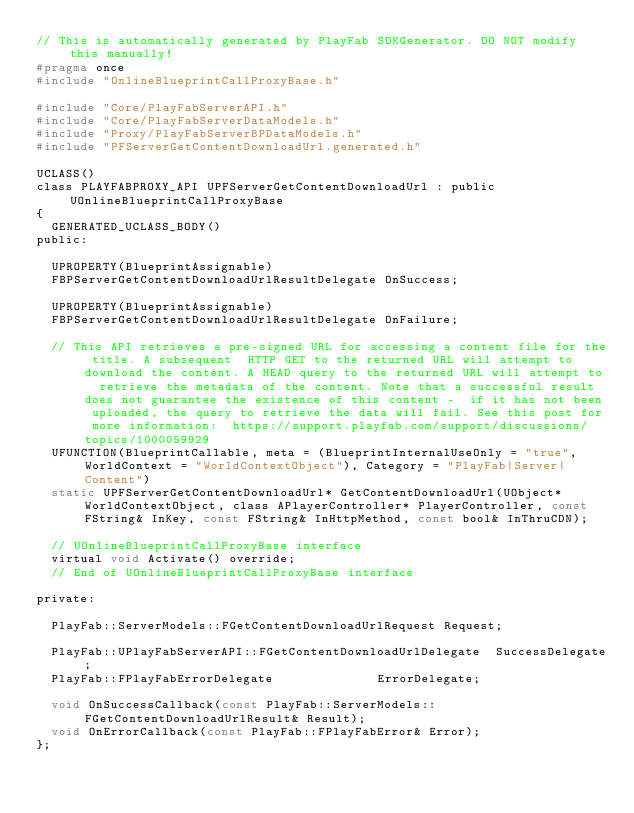Convert code to text. <code><loc_0><loc_0><loc_500><loc_500><_C_>// This is automatically generated by PlayFab SDKGenerator. DO NOT modify this manually!
#pragma once
#include "OnlineBlueprintCallProxyBase.h"

#include "Core/PlayFabServerAPI.h"
#include "Core/PlayFabServerDataModels.h"
#include "Proxy/PlayFabServerBPDataModels.h"
#include "PFServerGetContentDownloadUrl.generated.h"

UCLASS()
class PLAYFABPROXY_API UPFServerGetContentDownloadUrl : public UOnlineBlueprintCallProxyBase
{
	GENERATED_UCLASS_BODY()
public:

	UPROPERTY(BlueprintAssignable)
	FBPServerGetContentDownloadUrlResultDelegate OnSuccess;

	UPROPERTY(BlueprintAssignable)
	FBPServerGetContentDownloadUrlResultDelegate OnFailure;
	
	// This API retrieves a pre-signed URL for accessing a content file for the title. A subsequent  HTTP GET to the returned URL will attempt to download the content. A HEAD query to the returned URL will attempt to  retrieve the metadata of the content. Note that a successful result does not guarantee the existence of this content -  if it has not been uploaded, the query to retrieve the data will fail. See this post for more information:  https://support.playfab.com/support/discussions/topics/1000059929
	UFUNCTION(BlueprintCallable, meta = (BlueprintInternalUseOnly = "true", WorldContext = "WorldContextObject"), Category = "PlayFab|Server|Content")
	static UPFServerGetContentDownloadUrl* GetContentDownloadUrl(UObject* WorldContextObject, class APlayerController* PlayerController, const FString& InKey, const FString& InHttpMethod, const bool& InThruCDN);

	// UOnlineBlueprintCallProxyBase interface
	virtual void Activate() override;
	// End of UOnlineBlueprintCallProxyBase interface

private:

	PlayFab::ServerModels::FGetContentDownloadUrlRequest Request;

	PlayFab::UPlayFabServerAPI::FGetContentDownloadUrlDelegate	SuccessDelegate;
	PlayFab::FPlayFabErrorDelegate							ErrorDelegate;

	void OnSuccessCallback(const PlayFab::ServerModels::FGetContentDownloadUrlResult& Result);
	void OnErrorCallback(const PlayFab::FPlayFabError& Error);
};
</code> 